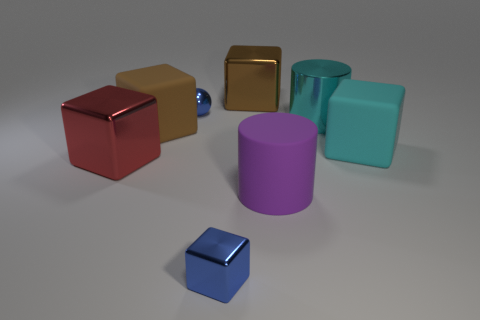How many other objects are the same size as the purple matte cylinder?
Ensure brevity in your answer.  5. The tiny metal object behind the blue metallic cube is what color?
Keep it short and to the point. Blue. Is the material of the brown thing that is to the left of the big brown shiny object the same as the cyan block?
Provide a short and direct response. Yes. How many objects are left of the big cyan rubber object and in front of the small blue metal sphere?
Ensure brevity in your answer.  5. There is a big cylinder behind the big cyan thing that is to the right of the cylinder that is behind the purple matte cylinder; what is its color?
Provide a succinct answer. Cyan. What number of other things are the same shape as the large cyan metallic thing?
Provide a short and direct response. 1. There is a blue metallic object in front of the large cyan metallic object; is there a brown shiny object that is on the left side of it?
Your answer should be very brief. No. What number of metallic objects are cyan things or small cubes?
Offer a very short reply. 2. There is a cube that is both on the right side of the small metal cube and in front of the brown matte block; what is its material?
Provide a succinct answer. Rubber. Are there any tiny blue objects behind the blue metal thing that is in front of the large brown thing in front of the brown metallic cube?
Make the answer very short. Yes. 